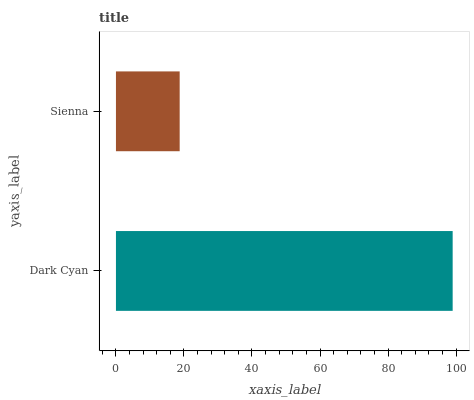Is Sienna the minimum?
Answer yes or no. Yes. Is Dark Cyan the maximum?
Answer yes or no. Yes. Is Sienna the maximum?
Answer yes or no. No. Is Dark Cyan greater than Sienna?
Answer yes or no. Yes. Is Sienna less than Dark Cyan?
Answer yes or no. Yes. Is Sienna greater than Dark Cyan?
Answer yes or no. No. Is Dark Cyan less than Sienna?
Answer yes or no. No. Is Dark Cyan the high median?
Answer yes or no. Yes. Is Sienna the low median?
Answer yes or no. Yes. Is Sienna the high median?
Answer yes or no. No. Is Dark Cyan the low median?
Answer yes or no. No. 